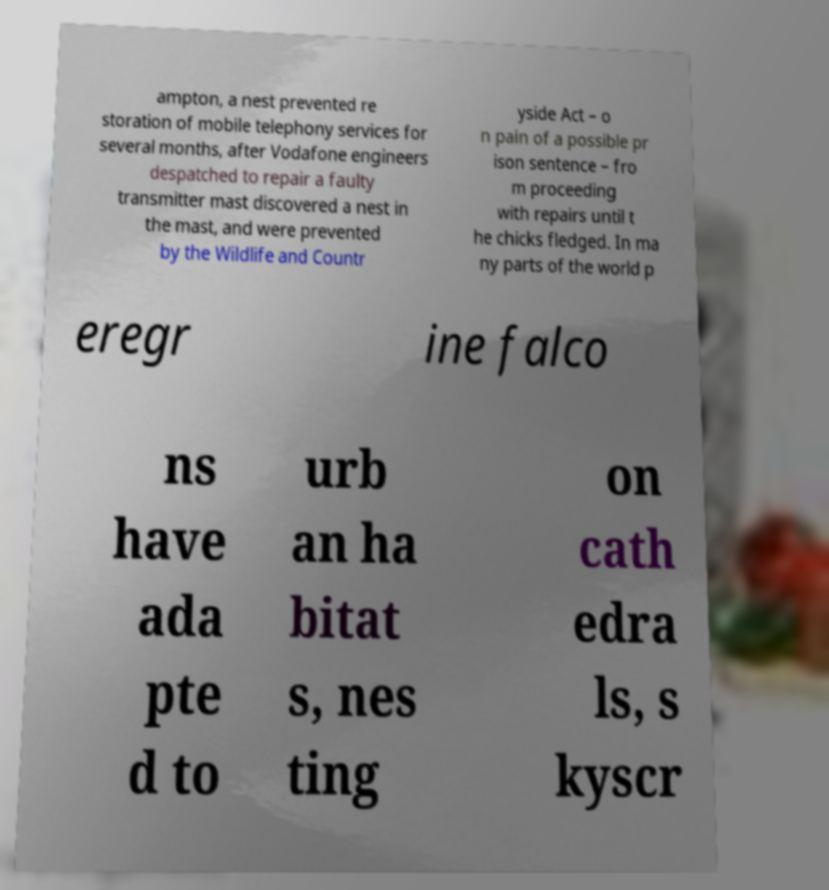Could you extract and type out the text from this image? ampton, a nest prevented re storation of mobile telephony services for several months, after Vodafone engineers despatched to repair a faulty transmitter mast discovered a nest in the mast, and were prevented by the Wildlife and Countr yside Act – o n pain of a possible pr ison sentence – fro m proceeding with repairs until t he chicks fledged. In ma ny parts of the world p eregr ine falco ns have ada pte d to urb an ha bitat s, nes ting on cath edra ls, s kyscr 